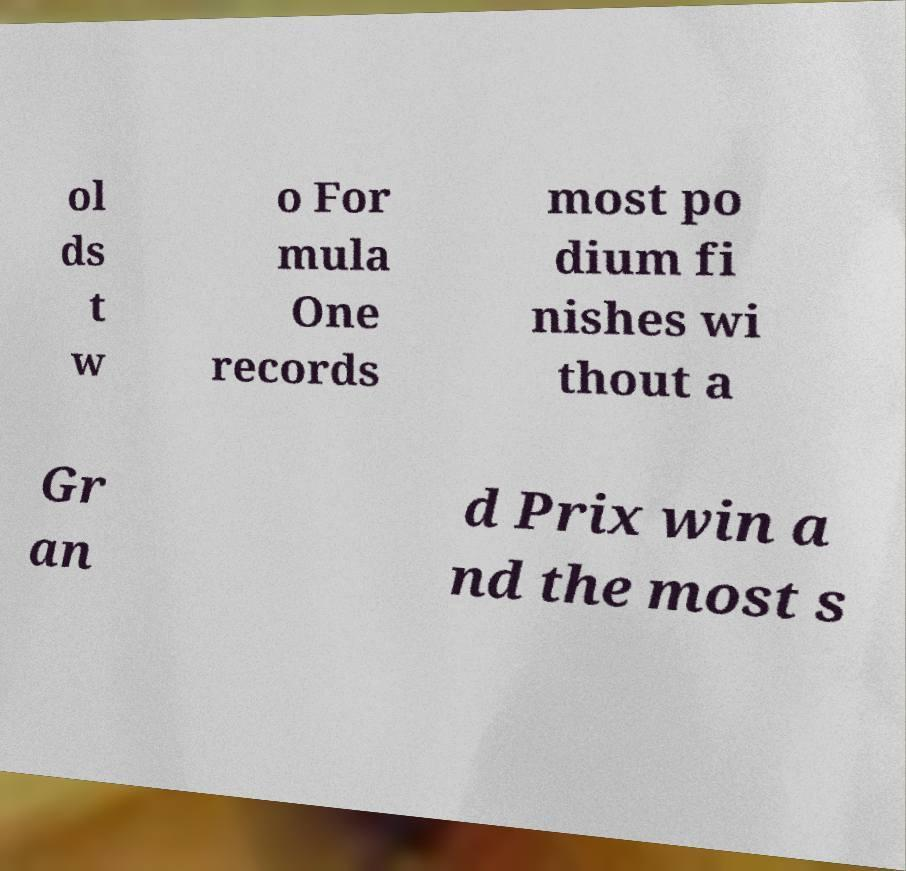There's text embedded in this image that I need extracted. Can you transcribe it verbatim? ol ds t w o For mula One records most po dium fi nishes wi thout a Gr an d Prix win a nd the most s 